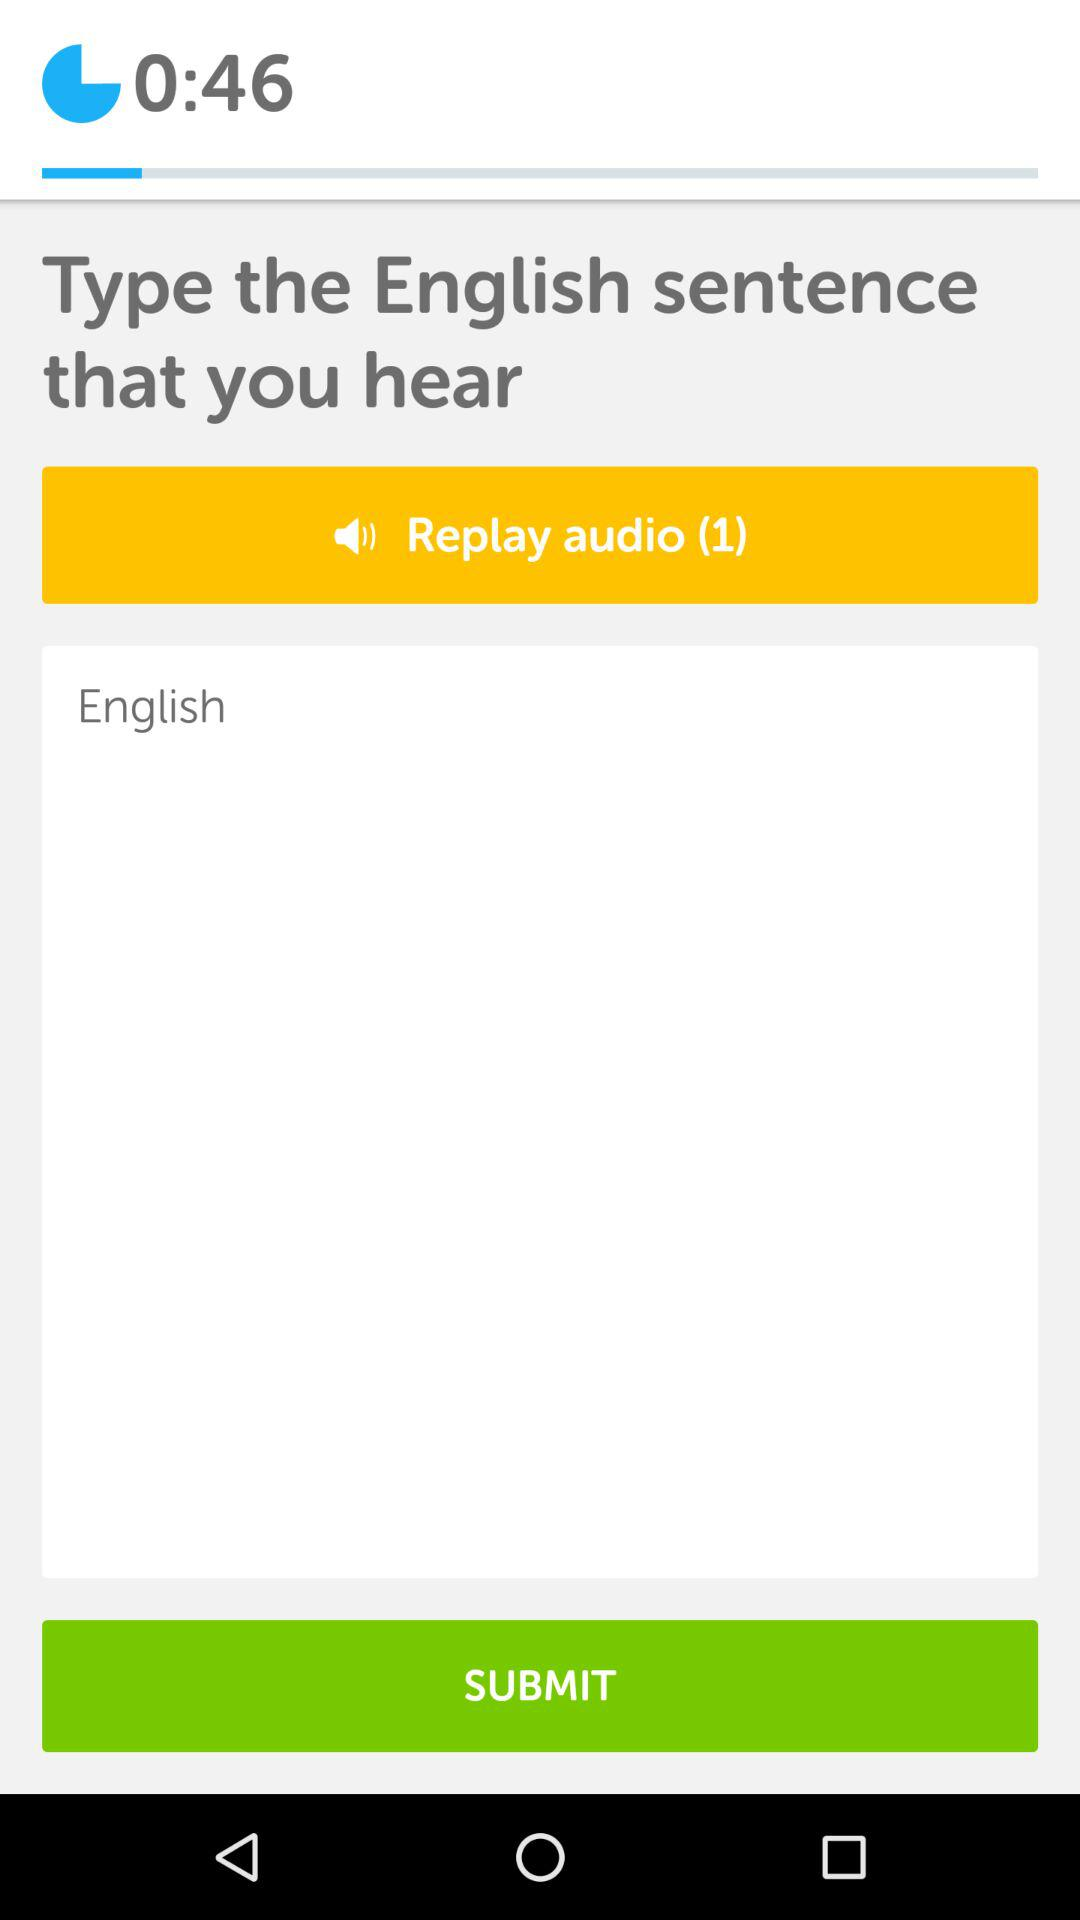What is the remaining time to type the English sentence? The remaining time is 45 seconds. 